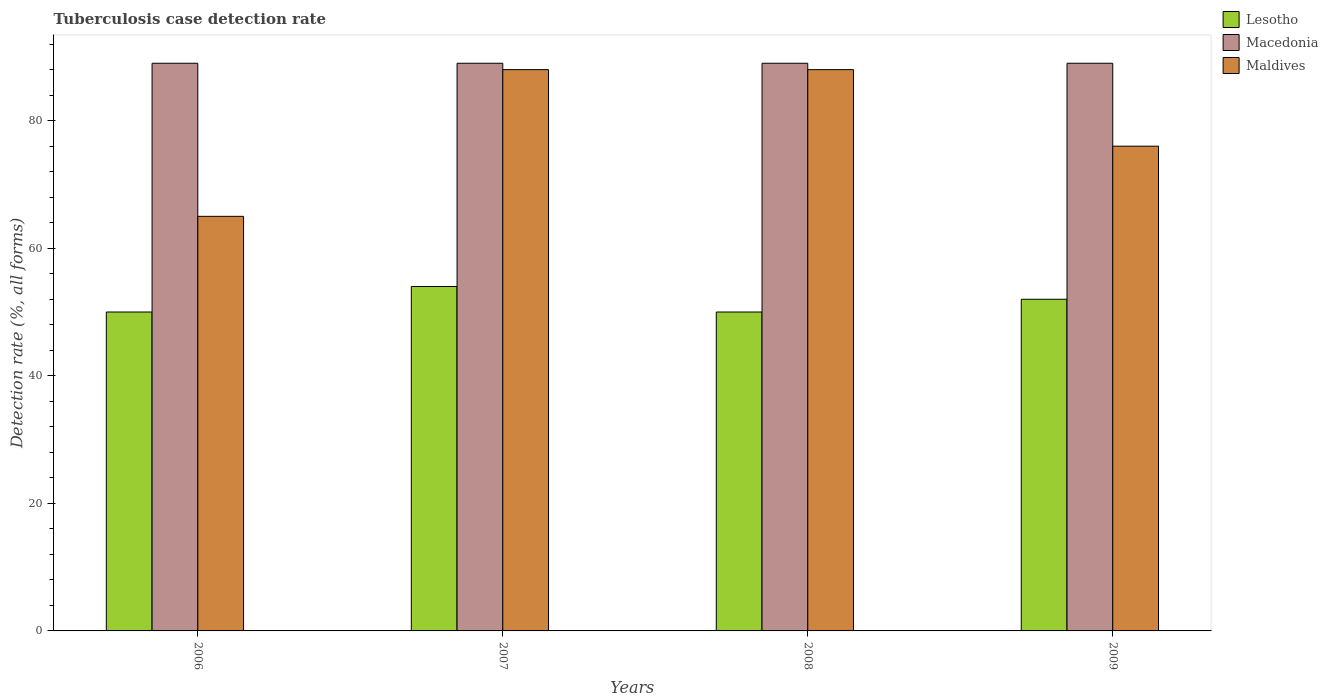Are the number of bars on each tick of the X-axis equal?
Ensure brevity in your answer.  Yes. How many bars are there on the 4th tick from the left?
Give a very brief answer. 3. What is the label of the 1st group of bars from the left?
Your answer should be compact. 2006. In how many cases, is the number of bars for a given year not equal to the number of legend labels?
Make the answer very short. 0. What is the tuberculosis case detection rate in in Maldives in 2009?
Your response must be concise. 76. Across all years, what is the maximum tuberculosis case detection rate in in Lesotho?
Give a very brief answer. 54. Across all years, what is the minimum tuberculosis case detection rate in in Macedonia?
Provide a short and direct response. 89. In which year was the tuberculosis case detection rate in in Macedonia minimum?
Make the answer very short. 2006. What is the total tuberculosis case detection rate in in Lesotho in the graph?
Your answer should be very brief. 206. What is the difference between the tuberculosis case detection rate in in Maldives in 2006 and that in 2008?
Ensure brevity in your answer.  -23. What is the average tuberculosis case detection rate in in Maldives per year?
Your response must be concise. 79.25. In the year 2009, what is the difference between the tuberculosis case detection rate in in Lesotho and tuberculosis case detection rate in in Macedonia?
Offer a very short reply. -37. In how many years, is the tuberculosis case detection rate in in Macedonia greater than 20 %?
Ensure brevity in your answer.  4. What is the ratio of the tuberculosis case detection rate in in Macedonia in 2007 to that in 2008?
Keep it short and to the point. 1. Is the tuberculosis case detection rate in in Maldives in 2006 less than that in 2009?
Provide a short and direct response. Yes. Is the difference between the tuberculosis case detection rate in in Lesotho in 2008 and 2009 greater than the difference between the tuberculosis case detection rate in in Macedonia in 2008 and 2009?
Your response must be concise. No. What is the difference between the highest and the second highest tuberculosis case detection rate in in Macedonia?
Your response must be concise. 0. What is the difference between the highest and the lowest tuberculosis case detection rate in in Lesotho?
Your response must be concise. 4. What does the 2nd bar from the left in 2009 represents?
Make the answer very short. Macedonia. What does the 3rd bar from the right in 2006 represents?
Provide a short and direct response. Lesotho. Is it the case that in every year, the sum of the tuberculosis case detection rate in in Macedonia and tuberculosis case detection rate in in Maldives is greater than the tuberculosis case detection rate in in Lesotho?
Provide a succinct answer. Yes. How many bars are there?
Offer a very short reply. 12. Are all the bars in the graph horizontal?
Your answer should be very brief. No. How many years are there in the graph?
Your response must be concise. 4. What is the difference between two consecutive major ticks on the Y-axis?
Your answer should be compact. 20. Does the graph contain any zero values?
Keep it short and to the point. No. Does the graph contain grids?
Offer a terse response. No. How many legend labels are there?
Provide a succinct answer. 3. What is the title of the graph?
Provide a succinct answer. Tuberculosis case detection rate. What is the label or title of the Y-axis?
Your response must be concise. Detection rate (%, all forms). What is the Detection rate (%, all forms) of Lesotho in 2006?
Your response must be concise. 50. What is the Detection rate (%, all forms) in Macedonia in 2006?
Your answer should be compact. 89. What is the Detection rate (%, all forms) in Lesotho in 2007?
Make the answer very short. 54. What is the Detection rate (%, all forms) of Macedonia in 2007?
Your response must be concise. 89. What is the Detection rate (%, all forms) in Macedonia in 2008?
Give a very brief answer. 89. What is the Detection rate (%, all forms) in Macedonia in 2009?
Your answer should be compact. 89. What is the Detection rate (%, all forms) of Maldives in 2009?
Provide a succinct answer. 76. Across all years, what is the maximum Detection rate (%, all forms) of Macedonia?
Offer a terse response. 89. Across all years, what is the maximum Detection rate (%, all forms) in Maldives?
Keep it short and to the point. 88. Across all years, what is the minimum Detection rate (%, all forms) of Lesotho?
Provide a succinct answer. 50. Across all years, what is the minimum Detection rate (%, all forms) of Macedonia?
Make the answer very short. 89. What is the total Detection rate (%, all forms) of Lesotho in the graph?
Your answer should be very brief. 206. What is the total Detection rate (%, all forms) in Macedonia in the graph?
Keep it short and to the point. 356. What is the total Detection rate (%, all forms) of Maldives in the graph?
Your response must be concise. 317. What is the difference between the Detection rate (%, all forms) in Macedonia in 2006 and that in 2007?
Your answer should be very brief. 0. What is the difference between the Detection rate (%, all forms) of Macedonia in 2006 and that in 2008?
Make the answer very short. 0. What is the difference between the Detection rate (%, all forms) of Maldives in 2006 and that in 2008?
Provide a short and direct response. -23. What is the difference between the Detection rate (%, all forms) of Macedonia in 2007 and that in 2008?
Ensure brevity in your answer.  0. What is the difference between the Detection rate (%, all forms) in Lesotho in 2007 and that in 2009?
Your response must be concise. 2. What is the difference between the Detection rate (%, all forms) in Maldives in 2007 and that in 2009?
Provide a succinct answer. 12. What is the difference between the Detection rate (%, all forms) of Lesotho in 2006 and the Detection rate (%, all forms) of Macedonia in 2007?
Provide a succinct answer. -39. What is the difference between the Detection rate (%, all forms) of Lesotho in 2006 and the Detection rate (%, all forms) of Maldives in 2007?
Provide a short and direct response. -38. What is the difference between the Detection rate (%, all forms) of Lesotho in 2006 and the Detection rate (%, all forms) of Macedonia in 2008?
Your answer should be very brief. -39. What is the difference between the Detection rate (%, all forms) in Lesotho in 2006 and the Detection rate (%, all forms) in Maldives in 2008?
Provide a short and direct response. -38. What is the difference between the Detection rate (%, all forms) of Lesotho in 2006 and the Detection rate (%, all forms) of Macedonia in 2009?
Keep it short and to the point. -39. What is the difference between the Detection rate (%, all forms) of Macedonia in 2006 and the Detection rate (%, all forms) of Maldives in 2009?
Provide a succinct answer. 13. What is the difference between the Detection rate (%, all forms) in Lesotho in 2007 and the Detection rate (%, all forms) in Macedonia in 2008?
Keep it short and to the point. -35. What is the difference between the Detection rate (%, all forms) of Lesotho in 2007 and the Detection rate (%, all forms) of Maldives in 2008?
Keep it short and to the point. -34. What is the difference between the Detection rate (%, all forms) of Lesotho in 2007 and the Detection rate (%, all forms) of Macedonia in 2009?
Offer a very short reply. -35. What is the difference between the Detection rate (%, all forms) of Lesotho in 2007 and the Detection rate (%, all forms) of Maldives in 2009?
Keep it short and to the point. -22. What is the difference between the Detection rate (%, all forms) of Lesotho in 2008 and the Detection rate (%, all forms) of Macedonia in 2009?
Provide a short and direct response. -39. What is the difference between the Detection rate (%, all forms) of Macedonia in 2008 and the Detection rate (%, all forms) of Maldives in 2009?
Provide a succinct answer. 13. What is the average Detection rate (%, all forms) in Lesotho per year?
Keep it short and to the point. 51.5. What is the average Detection rate (%, all forms) of Macedonia per year?
Your response must be concise. 89. What is the average Detection rate (%, all forms) of Maldives per year?
Your answer should be very brief. 79.25. In the year 2006, what is the difference between the Detection rate (%, all forms) in Lesotho and Detection rate (%, all forms) in Macedonia?
Offer a very short reply. -39. In the year 2007, what is the difference between the Detection rate (%, all forms) in Lesotho and Detection rate (%, all forms) in Macedonia?
Keep it short and to the point. -35. In the year 2007, what is the difference between the Detection rate (%, all forms) of Lesotho and Detection rate (%, all forms) of Maldives?
Make the answer very short. -34. In the year 2008, what is the difference between the Detection rate (%, all forms) in Lesotho and Detection rate (%, all forms) in Macedonia?
Provide a short and direct response. -39. In the year 2008, what is the difference between the Detection rate (%, all forms) of Lesotho and Detection rate (%, all forms) of Maldives?
Provide a succinct answer. -38. In the year 2008, what is the difference between the Detection rate (%, all forms) in Macedonia and Detection rate (%, all forms) in Maldives?
Make the answer very short. 1. In the year 2009, what is the difference between the Detection rate (%, all forms) of Lesotho and Detection rate (%, all forms) of Macedonia?
Your answer should be very brief. -37. In the year 2009, what is the difference between the Detection rate (%, all forms) in Lesotho and Detection rate (%, all forms) in Maldives?
Your response must be concise. -24. In the year 2009, what is the difference between the Detection rate (%, all forms) of Macedonia and Detection rate (%, all forms) of Maldives?
Your answer should be very brief. 13. What is the ratio of the Detection rate (%, all forms) in Lesotho in 2006 to that in 2007?
Offer a terse response. 0.93. What is the ratio of the Detection rate (%, all forms) of Maldives in 2006 to that in 2007?
Give a very brief answer. 0.74. What is the ratio of the Detection rate (%, all forms) of Macedonia in 2006 to that in 2008?
Keep it short and to the point. 1. What is the ratio of the Detection rate (%, all forms) in Maldives in 2006 to that in 2008?
Offer a terse response. 0.74. What is the ratio of the Detection rate (%, all forms) of Lesotho in 2006 to that in 2009?
Keep it short and to the point. 0.96. What is the ratio of the Detection rate (%, all forms) in Maldives in 2006 to that in 2009?
Your response must be concise. 0.86. What is the ratio of the Detection rate (%, all forms) of Macedonia in 2007 to that in 2008?
Your answer should be compact. 1. What is the ratio of the Detection rate (%, all forms) in Maldives in 2007 to that in 2009?
Your answer should be compact. 1.16. What is the ratio of the Detection rate (%, all forms) in Lesotho in 2008 to that in 2009?
Keep it short and to the point. 0.96. What is the ratio of the Detection rate (%, all forms) of Maldives in 2008 to that in 2009?
Your response must be concise. 1.16. What is the difference between the highest and the second highest Detection rate (%, all forms) of Macedonia?
Provide a short and direct response. 0. What is the difference between the highest and the second highest Detection rate (%, all forms) in Maldives?
Provide a succinct answer. 0. What is the difference between the highest and the lowest Detection rate (%, all forms) of Macedonia?
Offer a very short reply. 0. What is the difference between the highest and the lowest Detection rate (%, all forms) of Maldives?
Your answer should be compact. 23. 